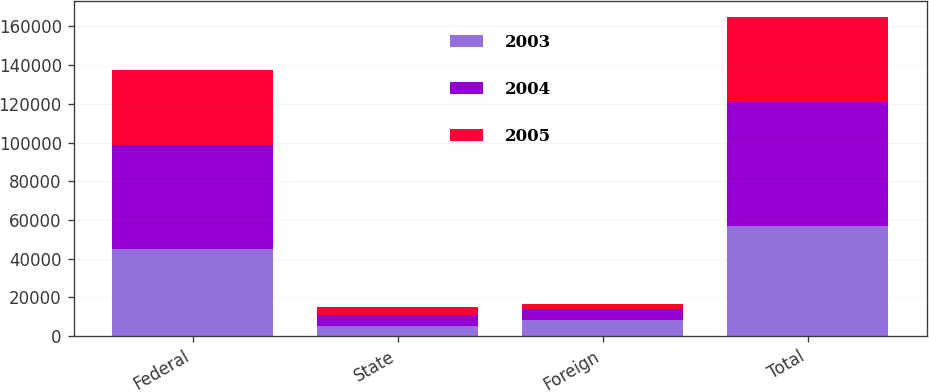<chart> <loc_0><loc_0><loc_500><loc_500><stacked_bar_chart><ecel><fcel>Federal<fcel>State<fcel>Foreign<fcel>Total<nl><fcel>2003<fcel>44736<fcel>5253<fcel>8060<fcel>56862<nl><fcel>2004<fcel>53810<fcel>5874<fcel>6023<fcel>63905<nl><fcel>2005<fcel>38954<fcel>3723<fcel>2561<fcel>44296<nl></chart> 